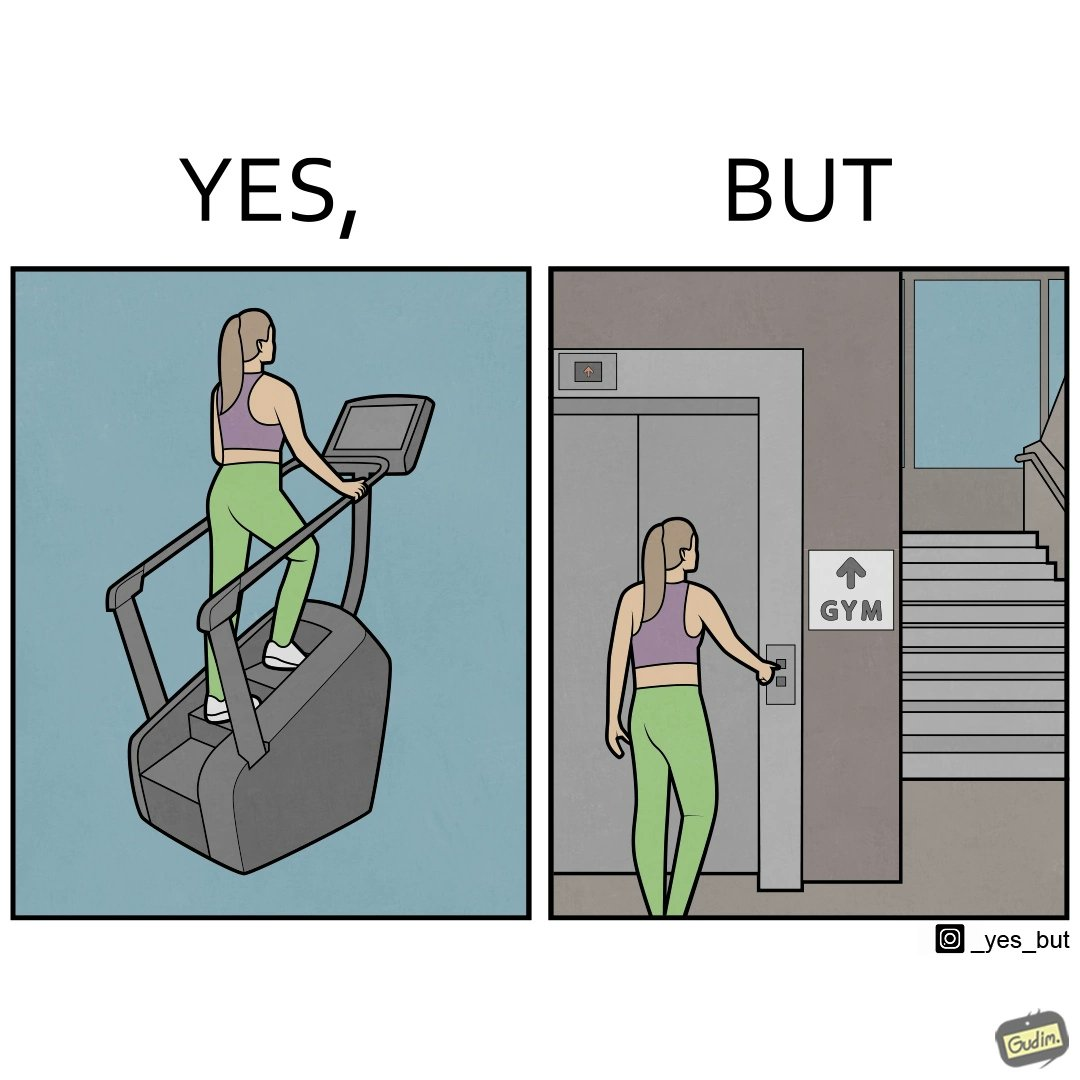Is this image satirical or non-satirical? Yes, this image is satirical. 